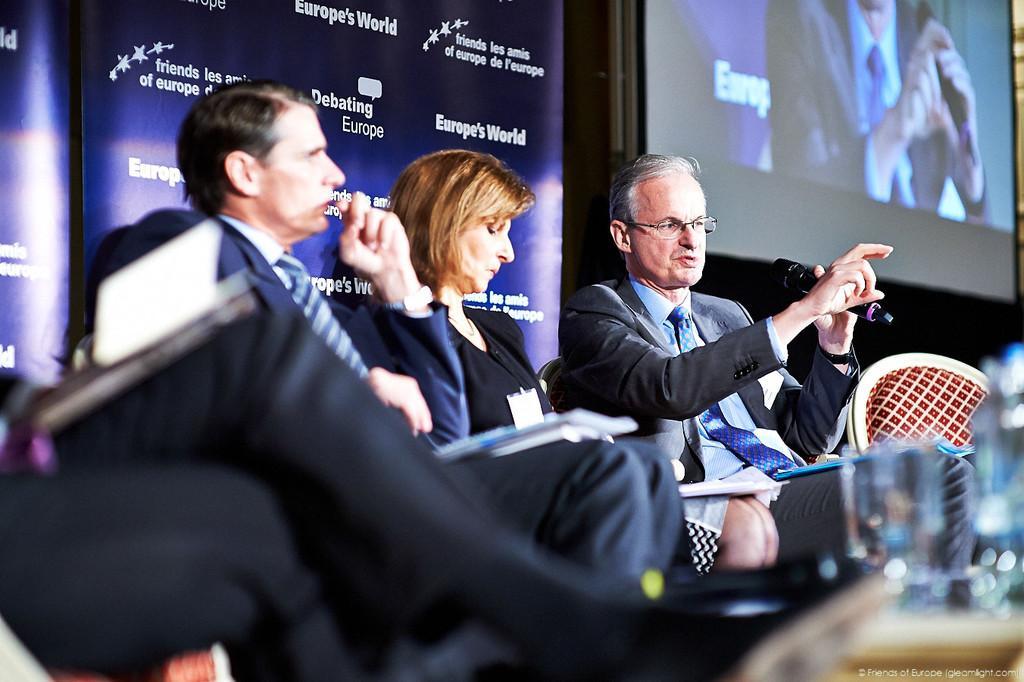Please provide a concise description of this image. This image consists of three persons wearing suits. In the background, we can see a screen and the banners. On the right, we can see a water bottle. 